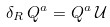<formula> <loc_0><loc_0><loc_500><loc_500>\delta _ { R } \, Q ^ { a } = Q ^ { a } \, \mathcal { U }</formula> 